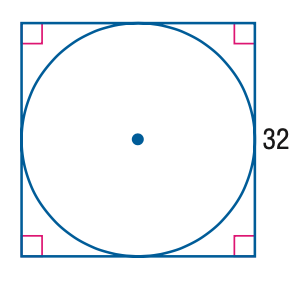Question: Find the exact circumference of the circle below.
Choices:
A. 16 \pi
B. 32 \pi
C. 128 \pi
D. 256 \pi
Answer with the letter. Answer: B 